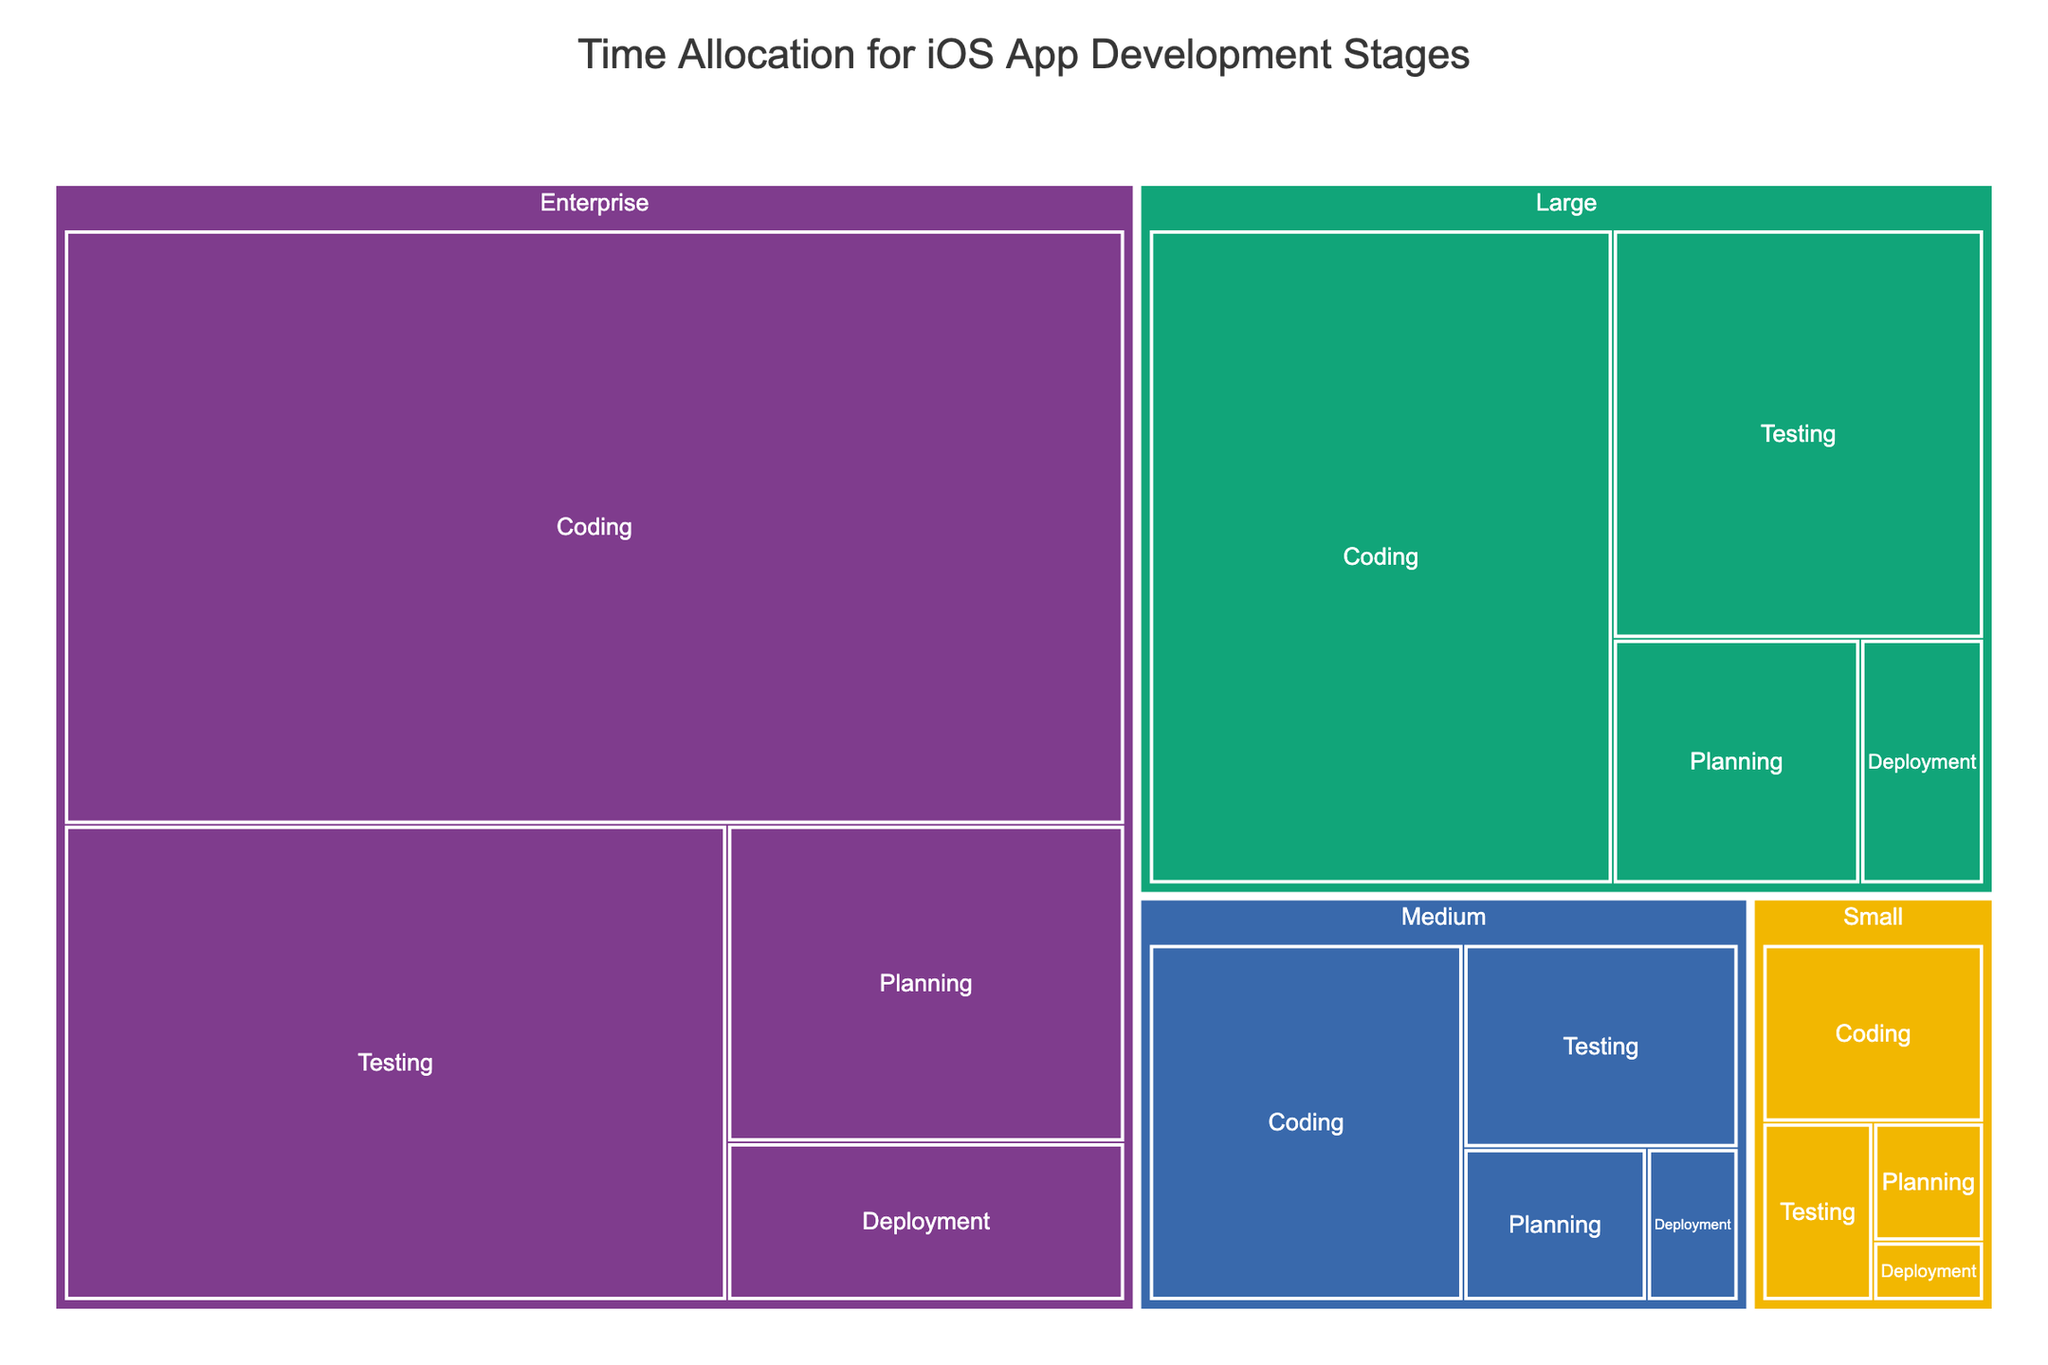What is the title of the treemap? The title is usually prominently displayed at the top of the treemap.
Answer: Time Allocation for iOS App Development Stages Which development stage takes the most time for a medium-sized project? Find the segment for 'Medium' projects, then locate the development stage with the largest area.
Answer: Coding How much time is allocated for testing in small and large projects combined? Add the time values for 'Testing' in Small and Large project sizes: 15 (Small) + 100 (Large).
Answer: 115 hours Which project size has the smallest time allocation for deployment? Compare the time values for 'Deployment' across all project sizes and find the smallest one.
Answer: Small What is the total time allocation for planning across all project sizes? Sum the time values for 'Planning' across all project sizes: 10 + 20 + 40 + 80.
Answer: 150 hours Does coding take more time in enterprise projects than the total of all stages in medium-sized projects? Compare the coding time in enterprise projects with the sum of all stages in medium-sized projects. Enterprise coding: 400. Medium total: 20 + 80 + 40 + 10 = 150.
Answer: Yes Which project size has the highest total time allocation? Compare the sum of time allocations for all stages in each project size.
Answer: Enterprise How much more time is spent on planning in medium projects compared to small projects? Subtract the planning time for small projects from that for medium projects: 20 - 10.
Answer: 10 hours Rank the development stages in descending order of time allocation for large projects. Compare and sort the values of the stages for large projects: 40 (Planning), 200 (Coding), 100 (Testing), 20 (Deployment).
Answer: Coding, Testing, Planning, Deployment What percentage of the total time is allocated to deployment in enterprise projects? Calculate the deployment time as a percentage of the sum of all stages for enterprise projects: (40 / (80 + 400 + 200 + 40)) * 100.
Answer: 5% 